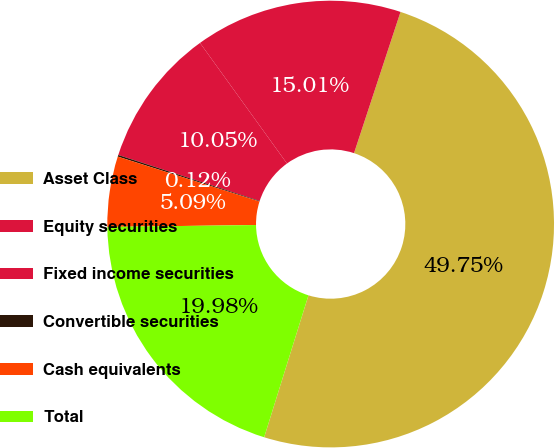Convert chart to OTSL. <chart><loc_0><loc_0><loc_500><loc_500><pie_chart><fcel>Asset Class<fcel>Equity securities<fcel>Fixed income securities<fcel>Convertible securities<fcel>Cash equivalents<fcel>Total<nl><fcel>49.75%<fcel>15.01%<fcel>10.05%<fcel>0.12%<fcel>5.09%<fcel>19.98%<nl></chart> 